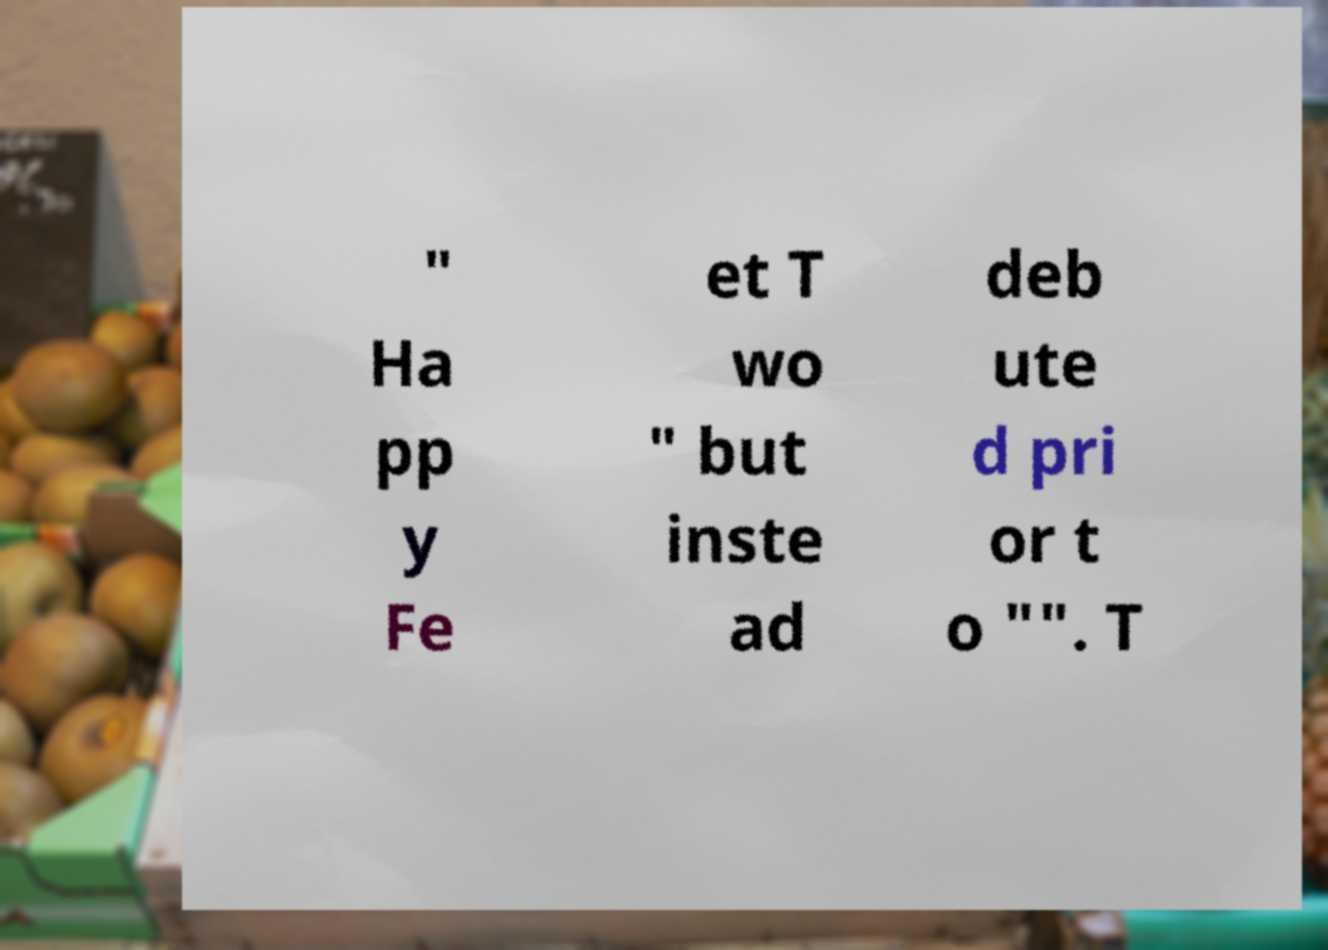For documentation purposes, I need the text within this image transcribed. Could you provide that? " Ha pp y Fe et T wo " but inste ad deb ute d pri or t o "". T 